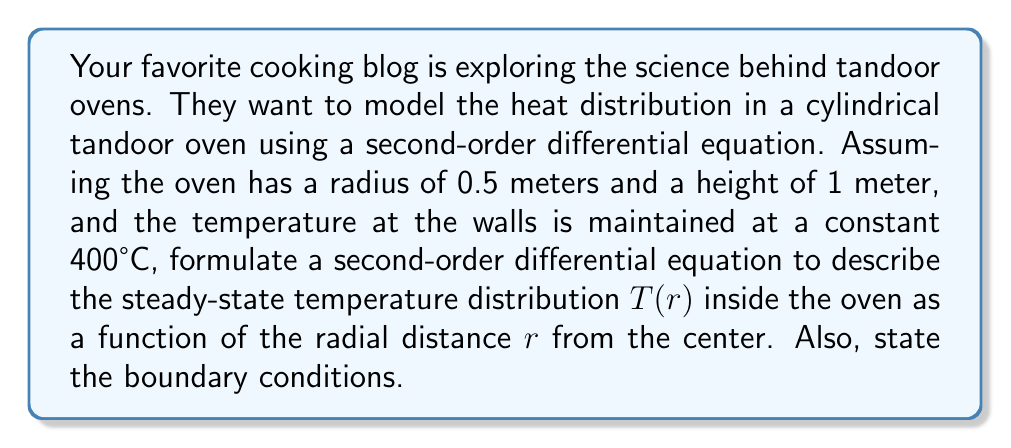Can you solve this math problem? To model the heat distribution in a cylindrical tandoor oven, we can use the steady-state heat equation in cylindrical coordinates. Since we're only concerned with the radial distribution and assuming symmetry, we can simplify this to a one-dimensional problem.

1. The general form of the steady-state heat equation in cylindrical coordinates is:

   $$\frac{1}{r}\frac{d}{dr}\left(r\frac{dT}{dr}\right) = 0$$

2. This can be expanded to:

   $$\frac{d^2T}{dr^2} + \frac{1}{r}\frac{dT}{dr} = 0$$

3. This is our second-order differential equation describing the temperature distribution $T(r)$ in the tandoor oven.

4. For the boundary conditions:
   - At the center of the oven ($r = 0$), the temperature gradient should be zero due to symmetry:
     $$\frac{dT}{dr}(0) = 0$$
   - At the wall of the oven ($r = 0.5$), the temperature is maintained at 400°C:
     $$T(0.5) = 400$$

These boundary conditions, along with the differential equation, fully describe the steady-state heat distribution problem in the tandoor oven.
Answer: The second-order differential equation describing the steady-state temperature distribution in the tandoor oven is:

$$\frac{d^2T}{dr^2} + \frac{1}{r}\frac{dT}{dr} = 0$$

with boundary conditions:

$$\frac{dT}{dr}(0) = 0$$
$$T(0.5) = 400$$ 